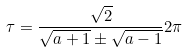Convert formula to latex. <formula><loc_0><loc_0><loc_500><loc_500>\tau = \frac { \sqrt { 2 } } { \sqrt { a + 1 } \pm \sqrt { a - 1 } } 2 \pi</formula> 